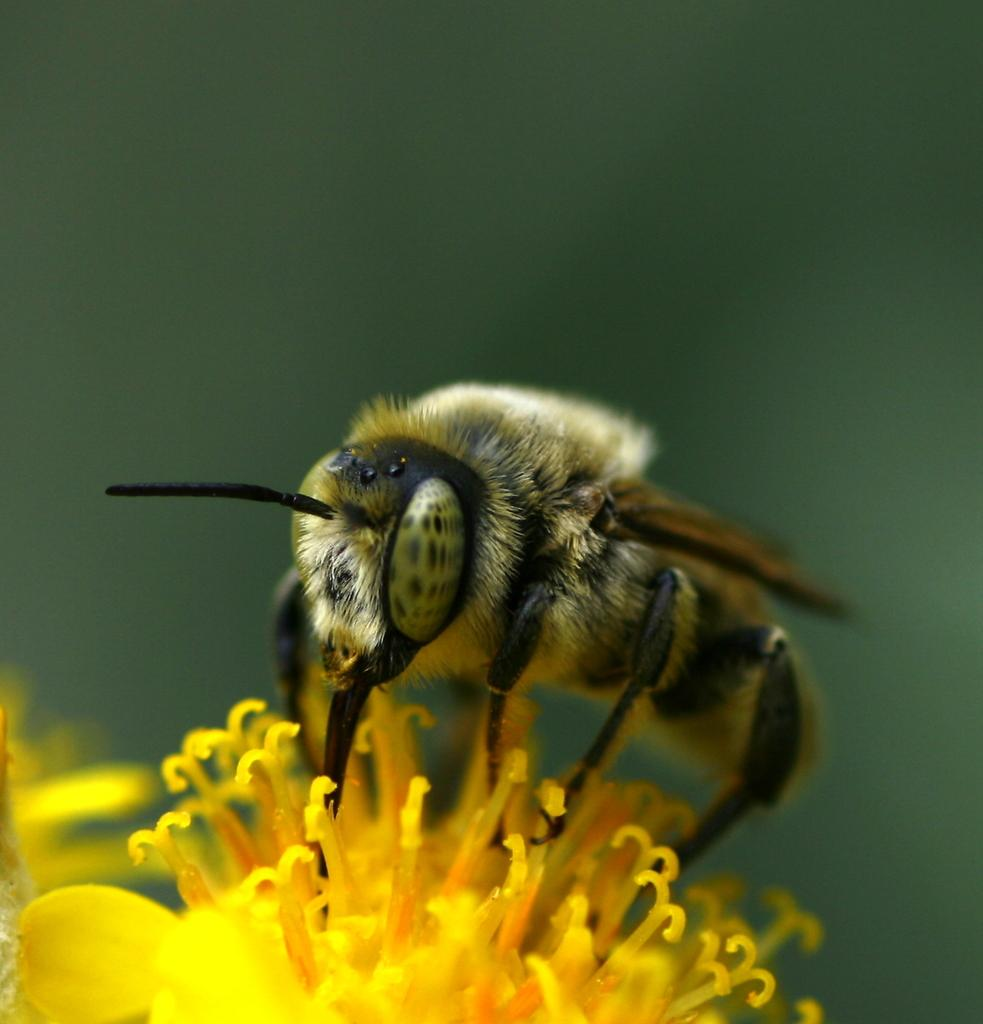What color are the buds in the image? The buds in the image are yellow-colored. What else can be seen in the image besides the buds? There is an insect in the image. Can you describe the appearance of the insect? The insect has a grey and black color. How would you describe the overall clarity of the image? The image is blurry in the background. What company is the insect working for in the image? There is no indication in the image that the insect is working for a company. Can you tell me how many knees the insect has in the image? Insects do not have knees like humans, and there is no need to count them in the image. 